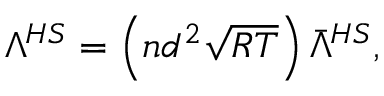<formula> <loc_0><loc_0><loc_500><loc_500>\begin{array} { r } { \Lambda ^ { H S } = \left ( n d ^ { 2 } \sqrt { R T } \right ) \bar { \Lambda } ^ { H S } , } \end{array}</formula> 